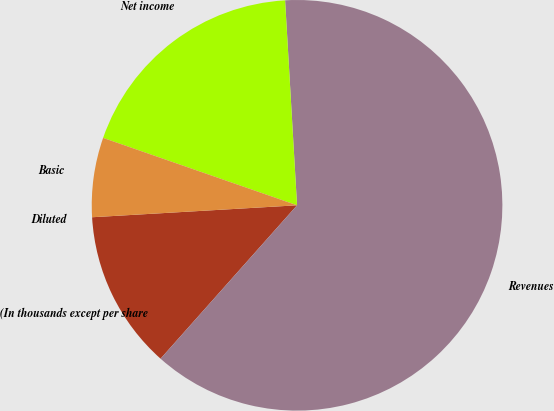<chart> <loc_0><loc_0><loc_500><loc_500><pie_chart><fcel>(In thousands except per share<fcel>Revenues<fcel>Net income<fcel>Basic<fcel>Diluted<nl><fcel>12.5%<fcel>62.5%<fcel>18.75%<fcel>6.25%<fcel>0.0%<nl></chart> 